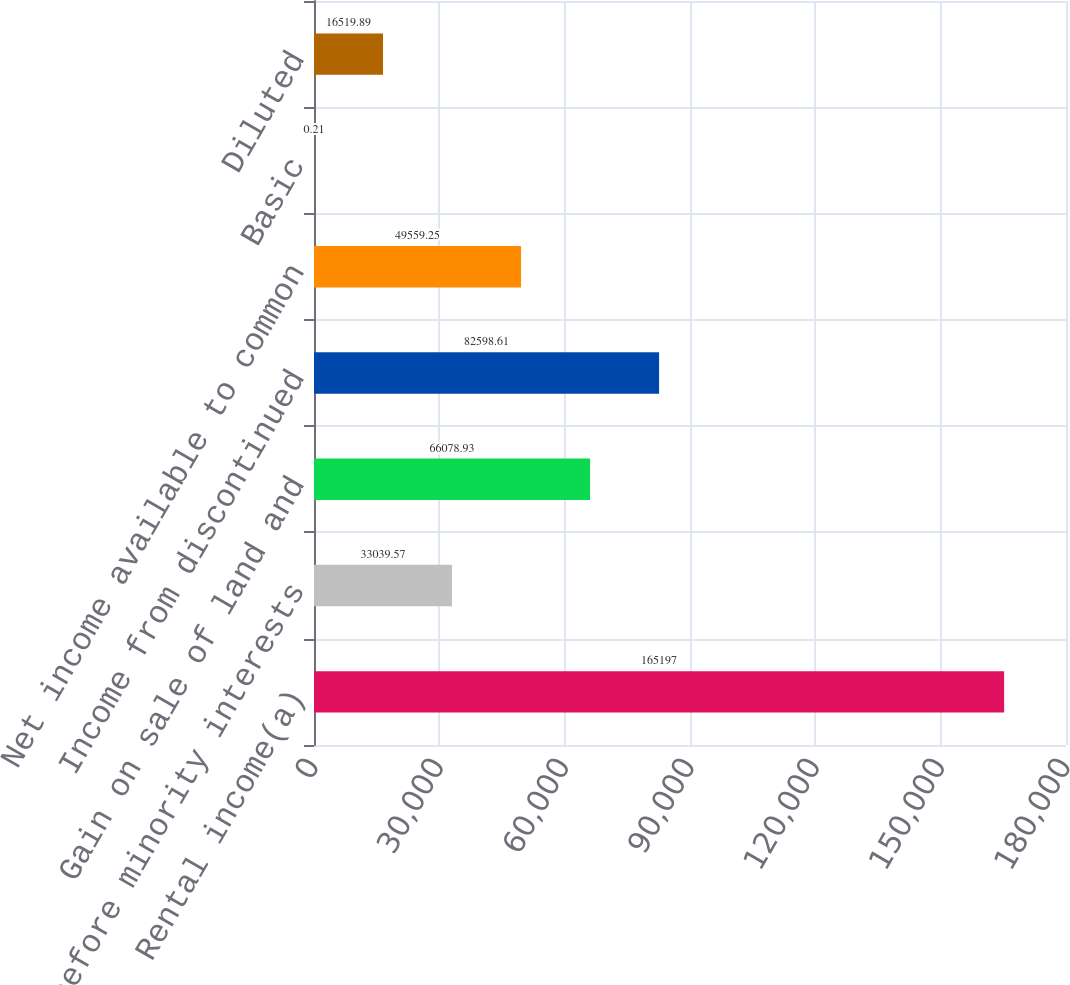Convert chart. <chart><loc_0><loc_0><loc_500><loc_500><bar_chart><fcel>Rental income(a)<fcel>Loss before minority interests<fcel>Gain on sale of land and<fcel>Income from discontinued<fcel>Net income available to common<fcel>Basic<fcel>Diluted<nl><fcel>165197<fcel>33039.6<fcel>66078.9<fcel>82598.6<fcel>49559.2<fcel>0.21<fcel>16519.9<nl></chart> 